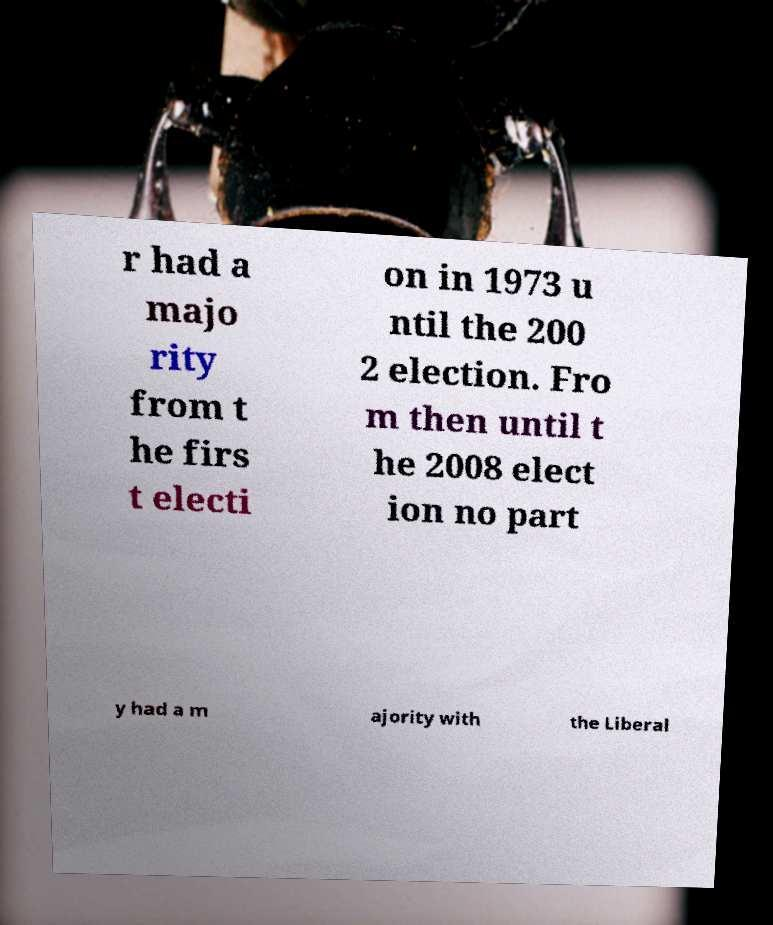Could you assist in decoding the text presented in this image and type it out clearly? r had a majo rity from t he firs t electi on in 1973 u ntil the 200 2 election. Fro m then until t he 2008 elect ion no part y had a m ajority with the Liberal 